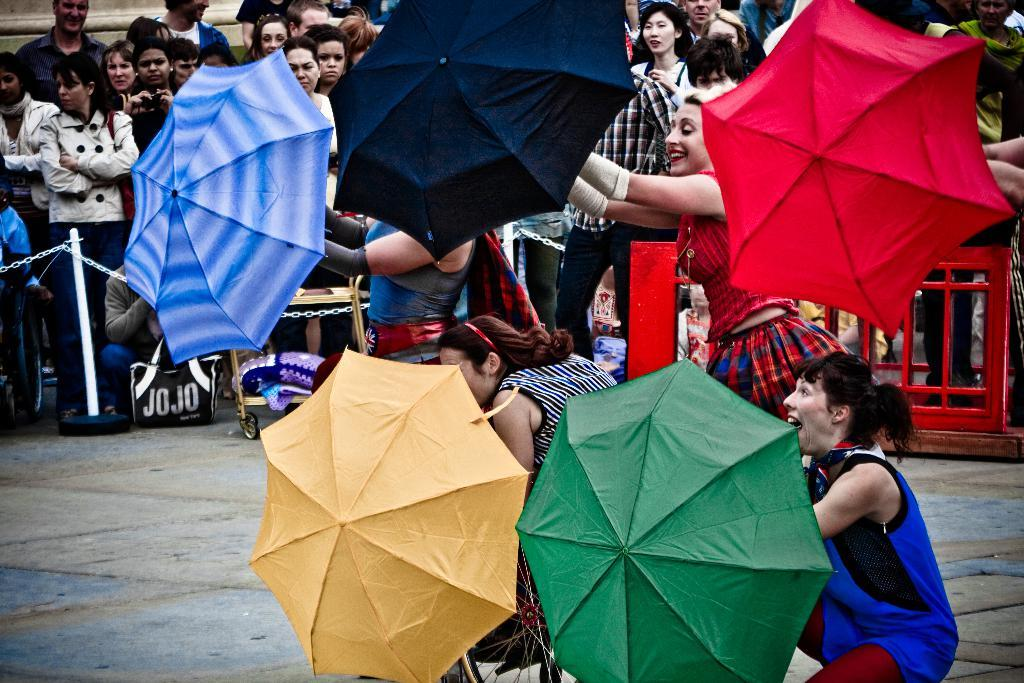Who is present in the image? There are women in the image. What are the women holding? The women are holding umbrellas. Can you describe the background of the image? There are many people behind the women, and they are standing in front of a fence. What type of paper is the woman reading in the image? There is no paper present in the image; the women are holding umbrellas. 